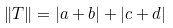Convert formula to latex. <formula><loc_0><loc_0><loc_500><loc_500>\| T \| = | a + b | + | c + d |</formula> 